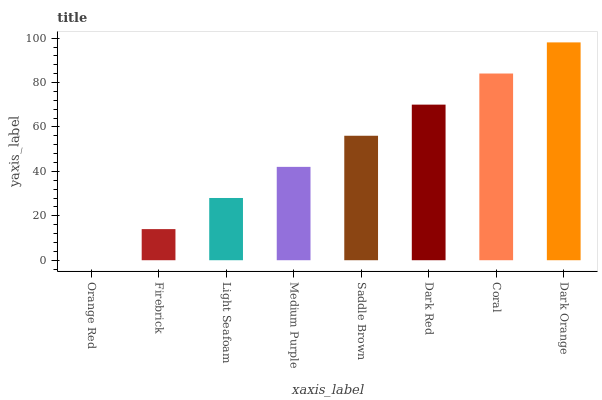Is Firebrick the minimum?
Answer yes or no. No. Is Firebrick the maximum?
Answer yes or no. No. Is Firebrick greater than Orange Red?
Answer yes or no. Yes. Is Orange Red less than Firebrick?
Answer yes or no. Yes. Is Orange Red greater than Firebrick?
Answer yes or no. No. Is Firebrick less than Orange Red?
Answer yes or no. No. Is Saddle Brown the high median?
Answer yes or no. Yes. Is Medium Purple the low median?
Answer yes or no. Yes. Is Coral the high median?
Answer yes or no. No. Is Saddle Brown the low median?
Answer yes or no. No. 